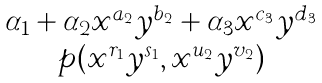<formula> <loc_0><loc_0><loc_500><loc_500>\begin{matrix} \alpha _ { 1 } + \alpha _ { 2 } x ^ { a _ { 2 } } y ^ { b _ { 2 } } + \alpha _ { 3 } x ^ { c _ { 3 } } y ^ { d _ { 3 } } \\ p ( x ^ { r _ { 1 } } y ^ { s _ { 1 } } , x ^ { u _ { 2 } } y ^ { v _ { 2 } } ) \end{matrix}</formula> 